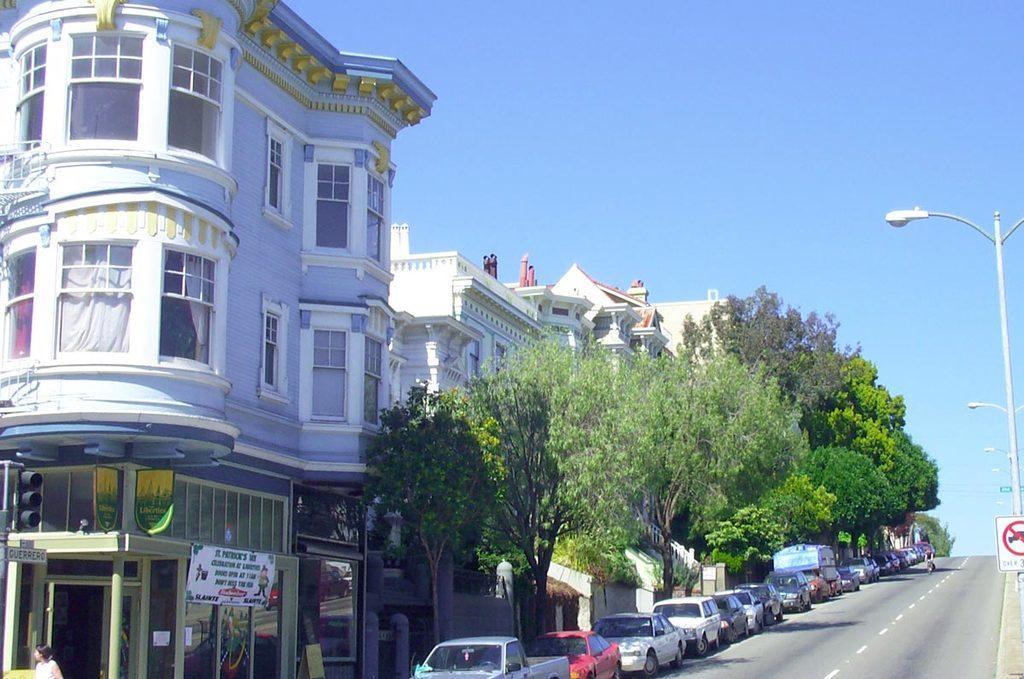Can you describe this image briefly? In this image there are so many buildings in front of that there are trees and some cars parked on the road, also there are electric poles. 